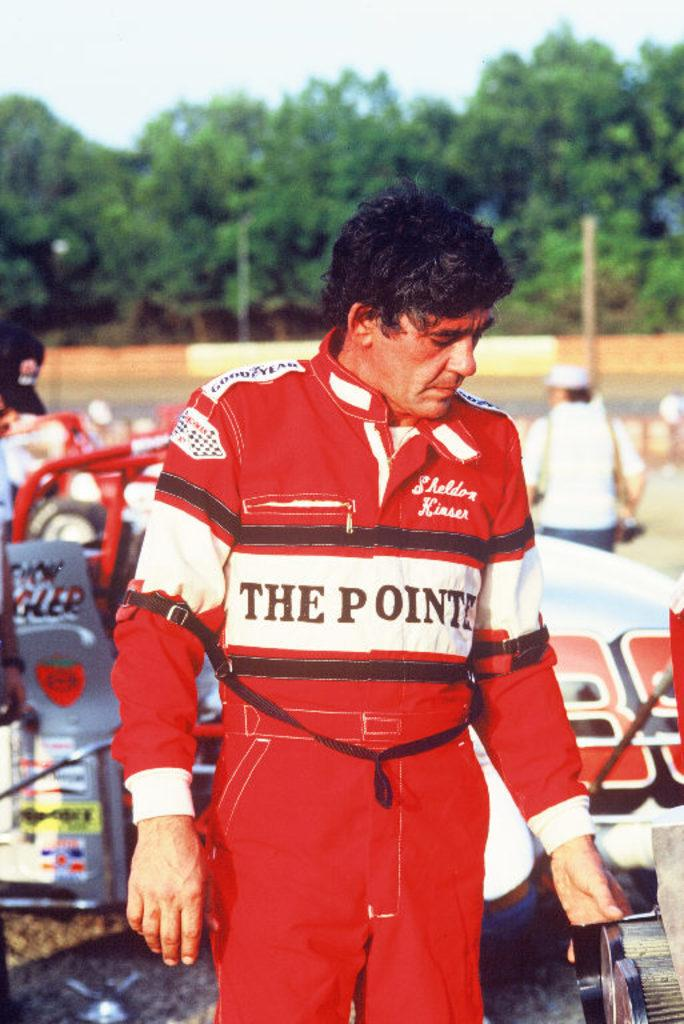<image>
Render a clear and concise summary of the photo. Sheldon Kinser is embroidered on to this race driver's uniform. 